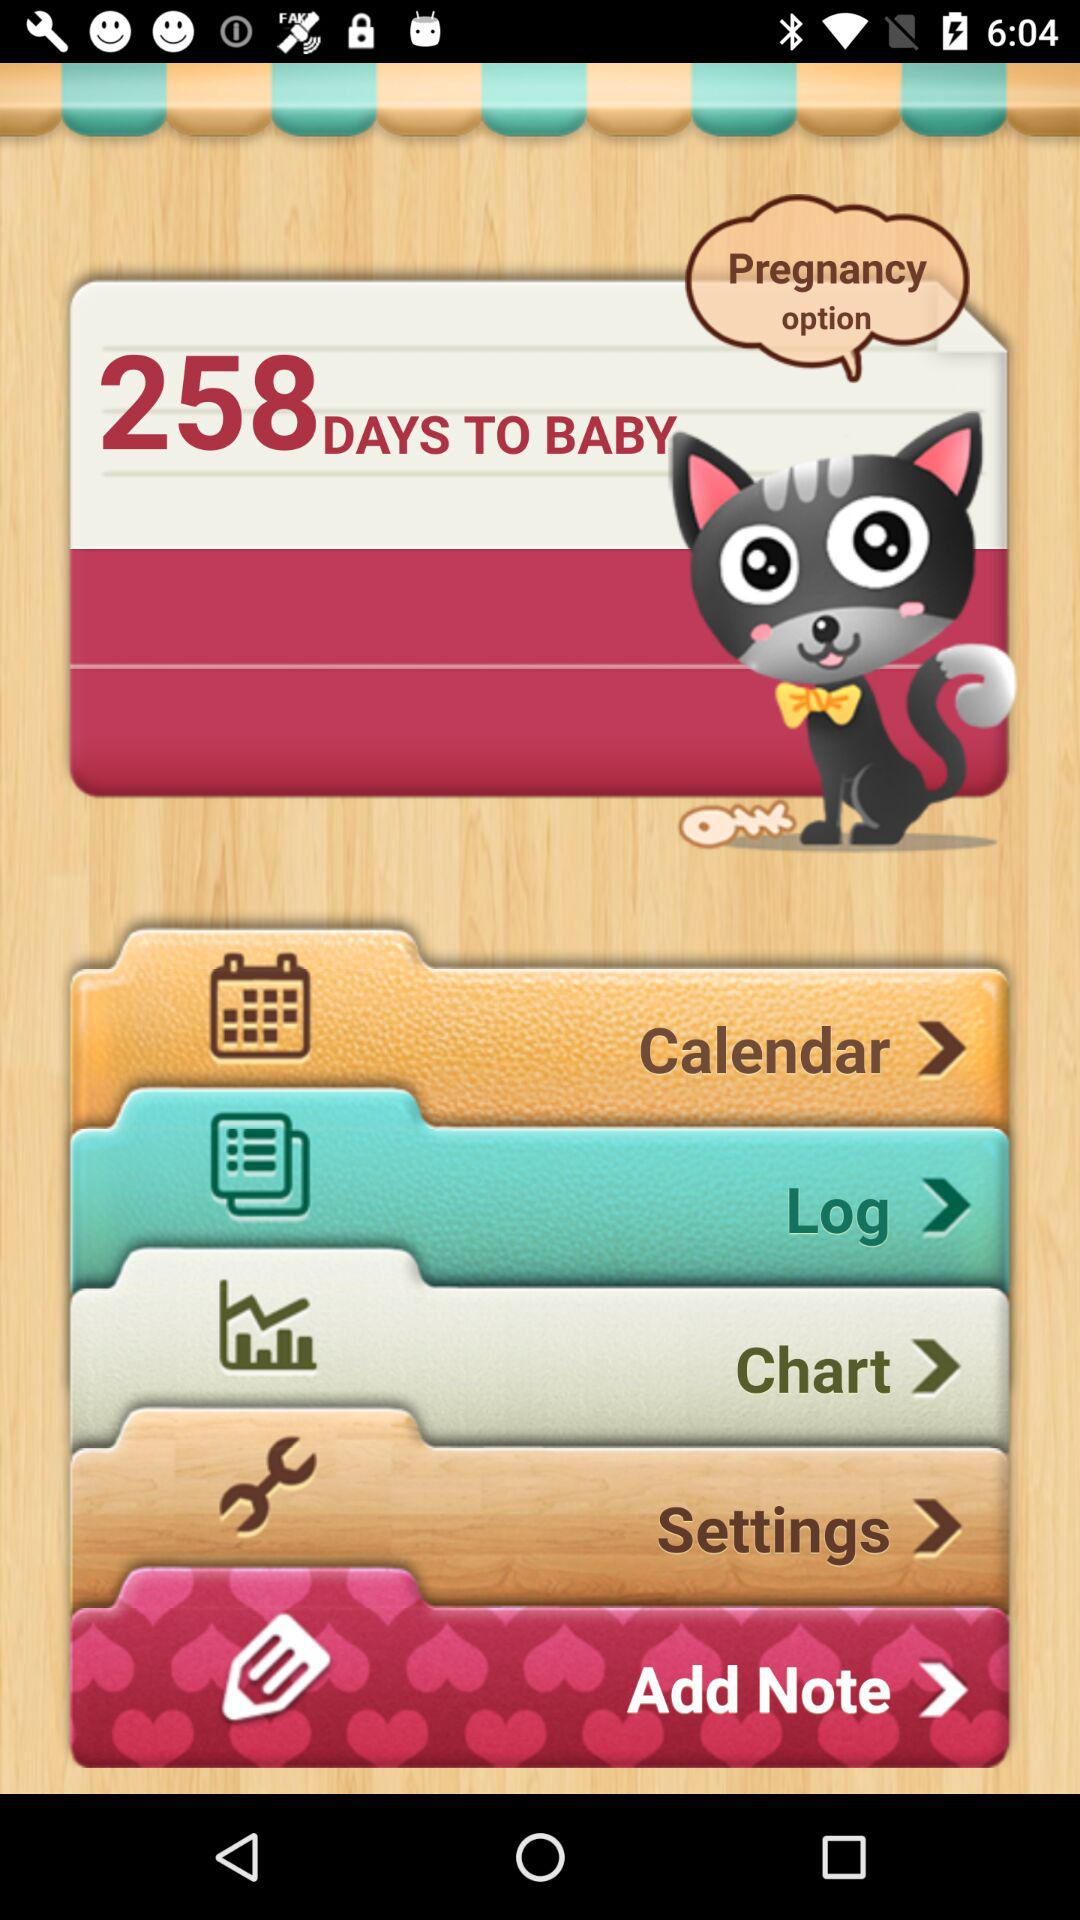How many days are left to have a baby? There are 258 days left to have a baby. 